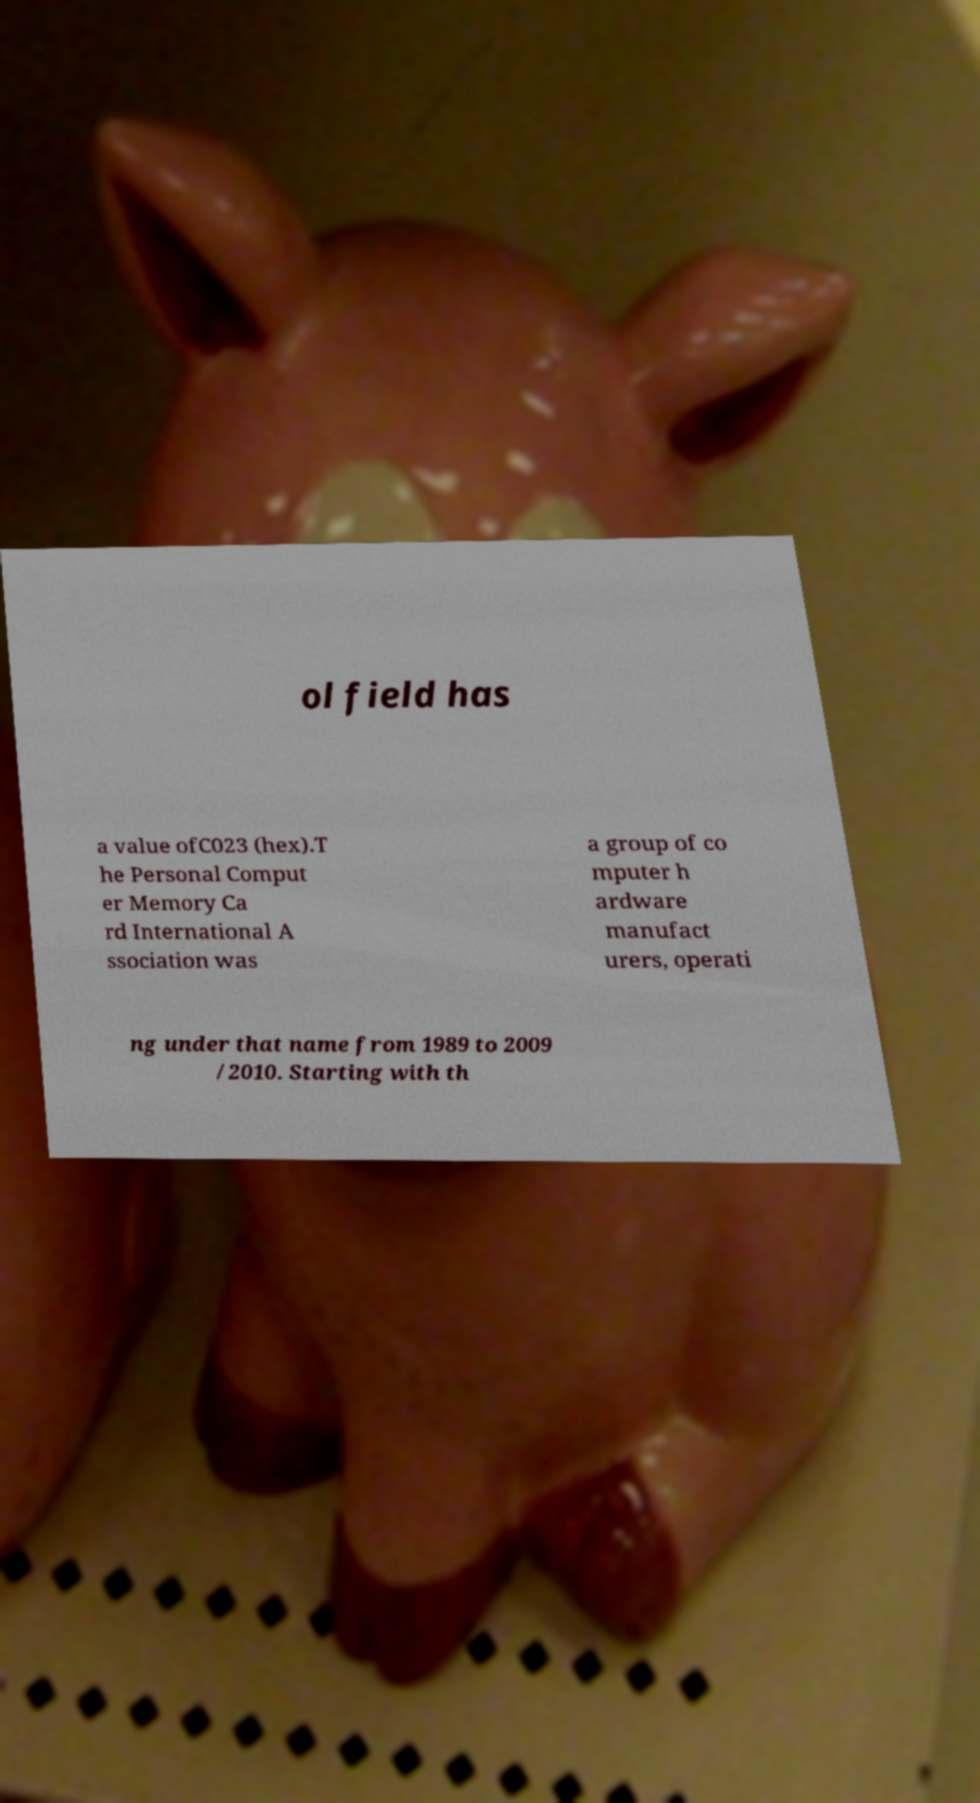There's text embedded in this image that I need extracted. Can you transcribe it verbatim? ol field has a value ofC023 (hex).T he Personal Comput er Memory Ca rd International A ssociation was a group of co mputer h ardware manufact urers, operati ng under that name from 1989 to 2009 /2010. Starting with th 